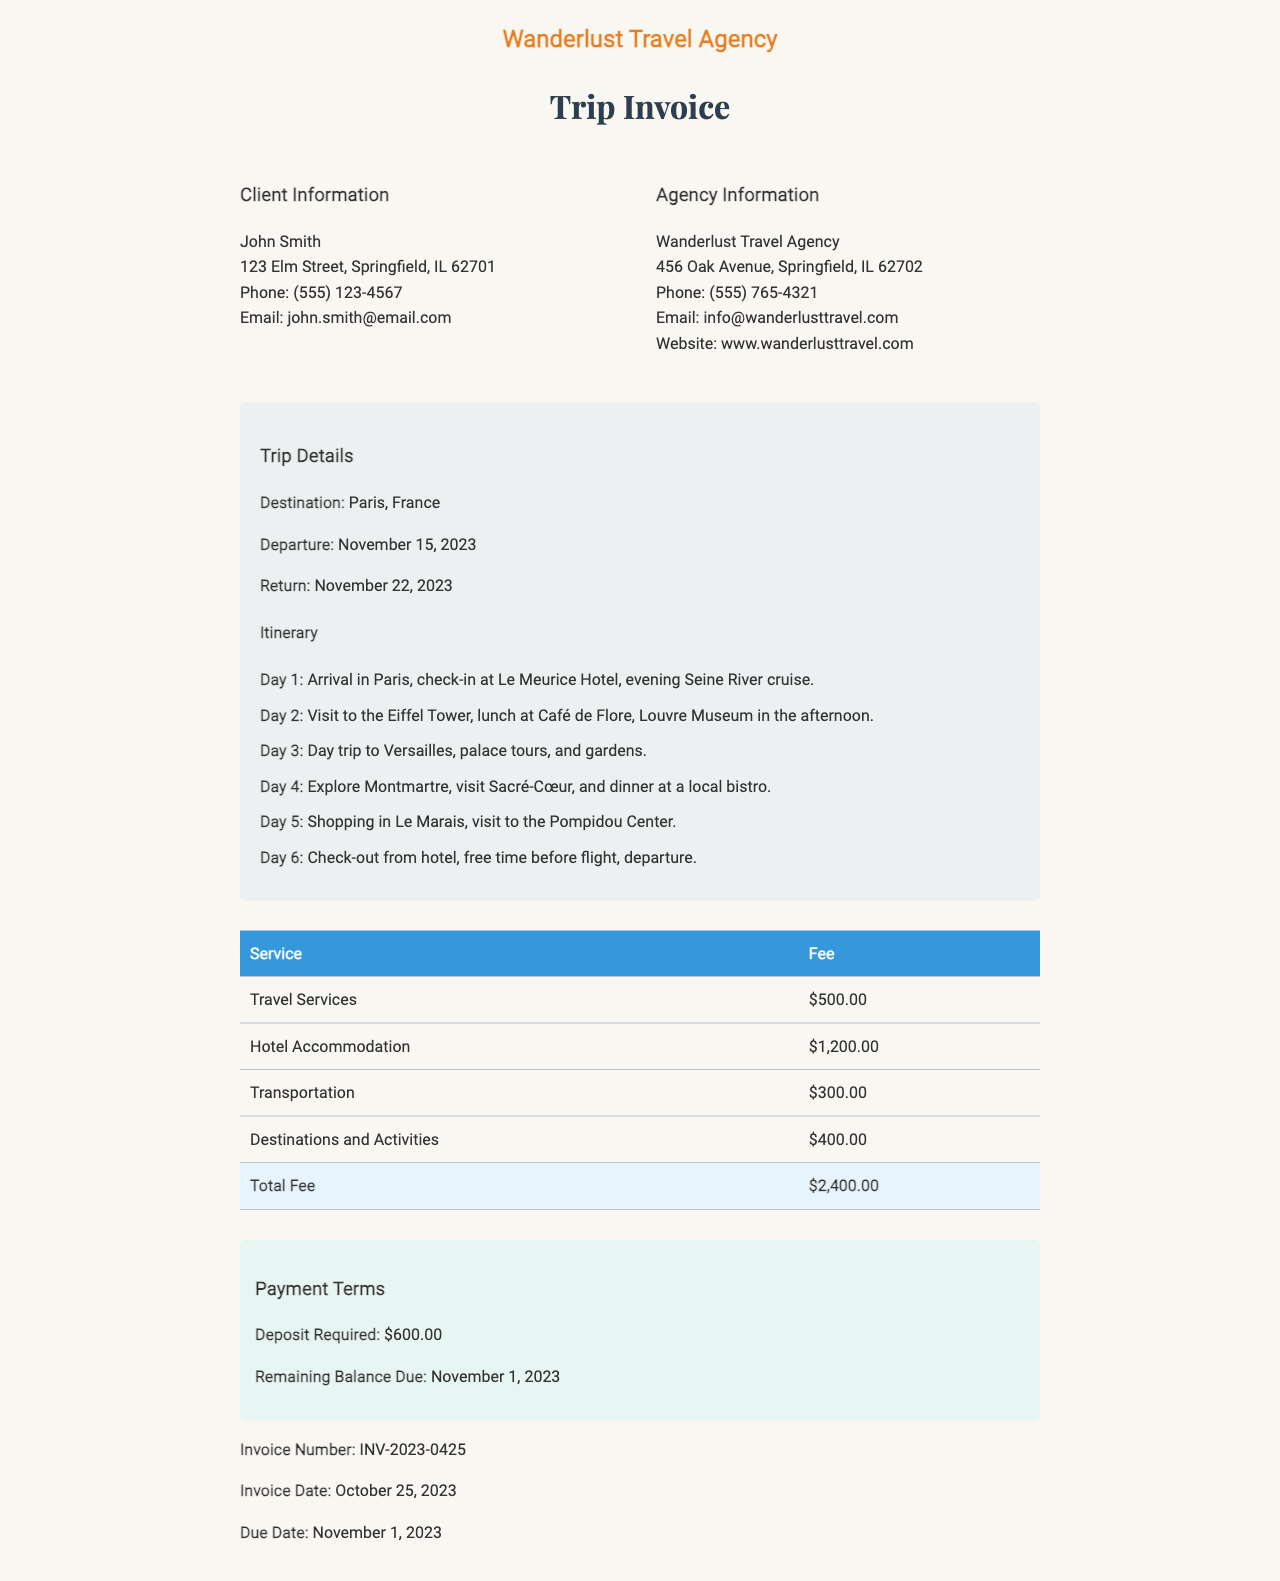What is the destination of the trip? The destination is specified in the trip details section of the document, which states "Paris, France".
Answer: Paris, France What is the total fee for the services? The total fee is stated at the bottom of the fees table, which summarizes the total of all fees listed.
Answer: $2,400.00 When is the return date of the trip? The return date is mentioned in the trip details section, indicating when the client will return.
Answer: November 22, 2023 Who is the client? The client information section lists the name of the client at the top as "John Smith".
Answer: John Smith What is the required deposit for the trip? The payment terms section specifies the amount that needs to be deposited before the trip begins.
Answer: $600.00 How many days is the itinerary? The itinerary outlines activities for each day, indicating the total number of days included in the trip.
Answer: 6 What hotel is the client checking into? The itinerary details the hotel where the client will be staying upon arrival in Paris.
Answer: Le Meurice Hotel What is the invoice number? The footer of the document provides a unique identifier for this particular invoice.
Answer: INV-2023-0425 When is the remaining balance due? The payment terms indicate the date by which the remaining balance must be paid.
Answer: November 1, 2023 